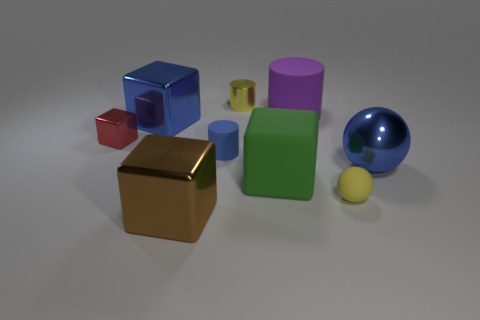Is the color of the big metallic ball the same as the small rubber cylinder?
Provide a succinct answer. Yes. What is the size of the ball that is the same material as the red thing?
Your answer should be compact. Large. Do the yellow thing that is in front of the tiny block and the big blue metallic thing to the right of the big purple rubber cylinder have the same shape?
Ensure brevity in your answer.  Yes. What color is the other cylinder that is made of the same material as the tiny blue cylinder?
Provide a short and direct response. Purple. Do the shiny object that is on the right side of the small yellow rubber ball and the yellow thing that is behind the yellow sphere have the same size?
Make the answer very short. No. There is a object that is in front of the green thing and left of the green cube; what is its shape?
Offer a terse response. Cube. Is there a small thing made of the same material as the big blue sphere?
Ensure brevity in your answer.  Yes. What is the material of the big ball that is the same color as the tiny matte cylinder?
Provide a succinct answer. Metal. Is the big thing that is left of the brown metal block made of the same material as the cube that is on the right side of the brown metal thing?
Your answer should be compact. No. Is the number of big rubber cubes greater than the number of balls?
Provide a succinct answer. No. 